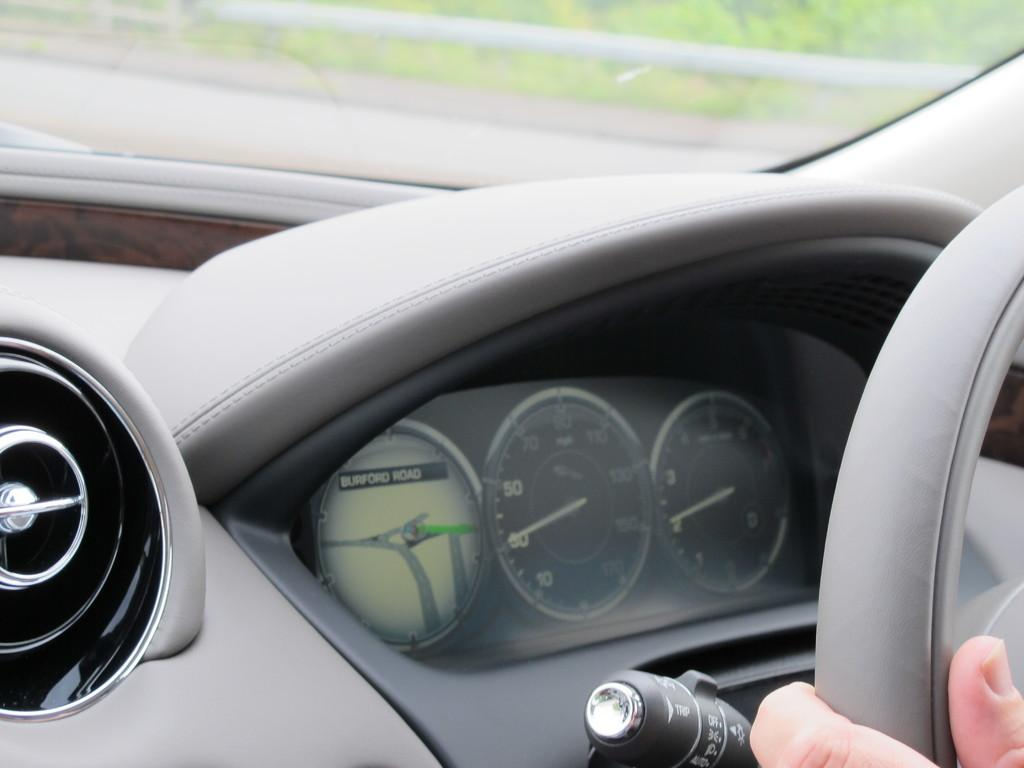What type of vehicle is shown in the image? The image shows an inside view of a car. Where is the steering wheel located in the car? The steering wheel is on the right side of the car. Whose fingers are visible in the image? Fingers are visible in the image, but it is not specified whose fingers they are. What can be seen through the glass in the image? Plants are visible through the glass in the image. How many clocks are hanging on the wall in the image? There are no clocks visible in the image; it shows an inside view of a car. What type of bells can be heard ringing in the background of the image? There is no sound present in the image, as it is a still photograph. 